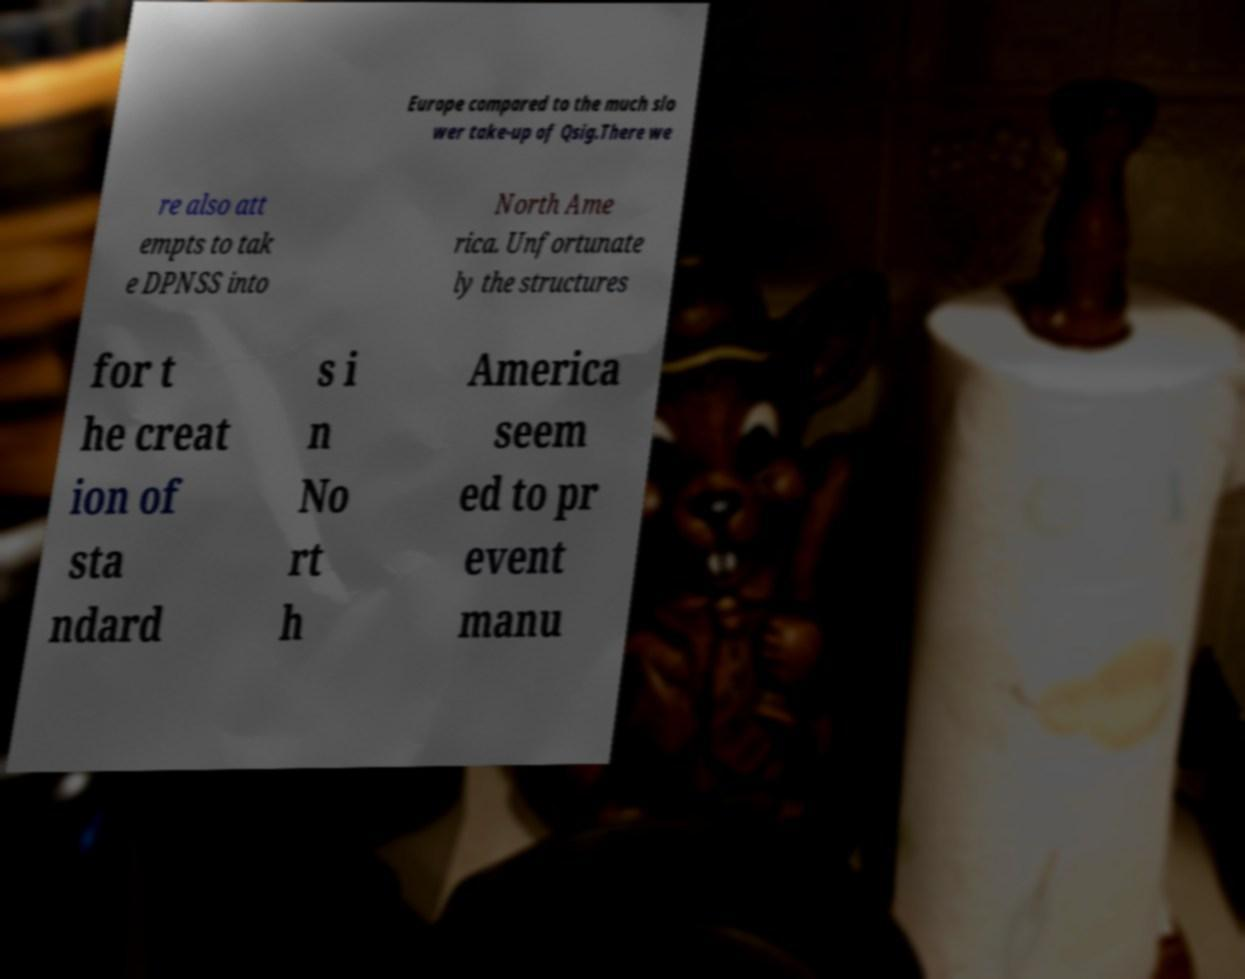Can you read and provide the text displayed in the image?This photo seems to have some interesting text. Can you extract and type it out for me? Europe compared to the much slo wer take-up of Qsig.There we re also att empts to tak e DPNSS into North Ame rica. Unfortunate ly the structures for t he creat ion of sta ndard s i n No rt h America seem ed to pr event manu 